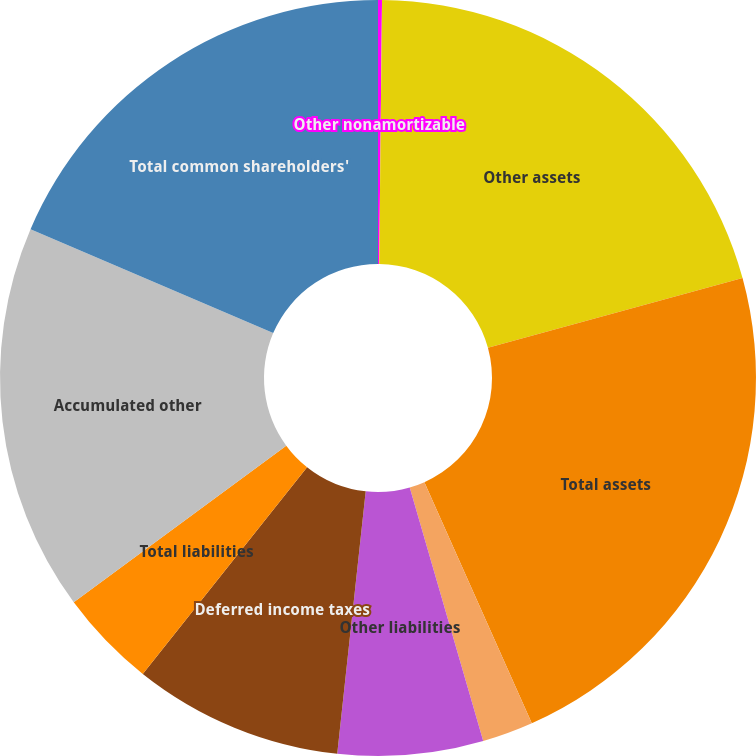Convert chart to OTSL. <chart><loc_0><loc_0><loc_500><loc_500><pie_chart><fcel>Other nonamortizable<fcel>Other assets<fcel>Total assets<fcel>Accounts payable and other<fcel>Other liabilities<fcel>Deferred income taxes<fcel>Total liabilities<fcel>Accumulated other<fcel>Total common shareholders'<nl><fcel>0.17%<fcel>20.57%<fcel>22.59%<fcel>2.18%<fcel>6.21%<fcel>8.97%<fcel>4.2%<fcel>16.55%<fcel>18.56%<nl></chart> 